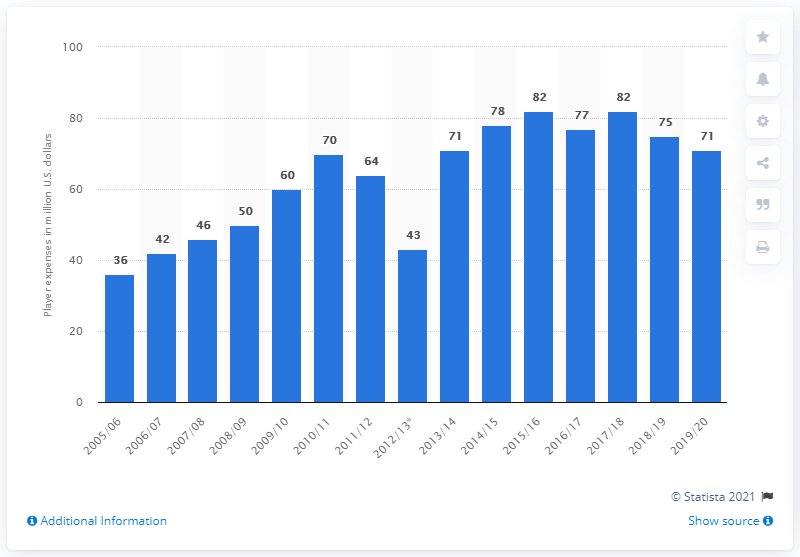Outline some significant characteristics in this image. In the 2019/2020 season, the Chicago Blackhawks had a total player expenses of $71 million. 